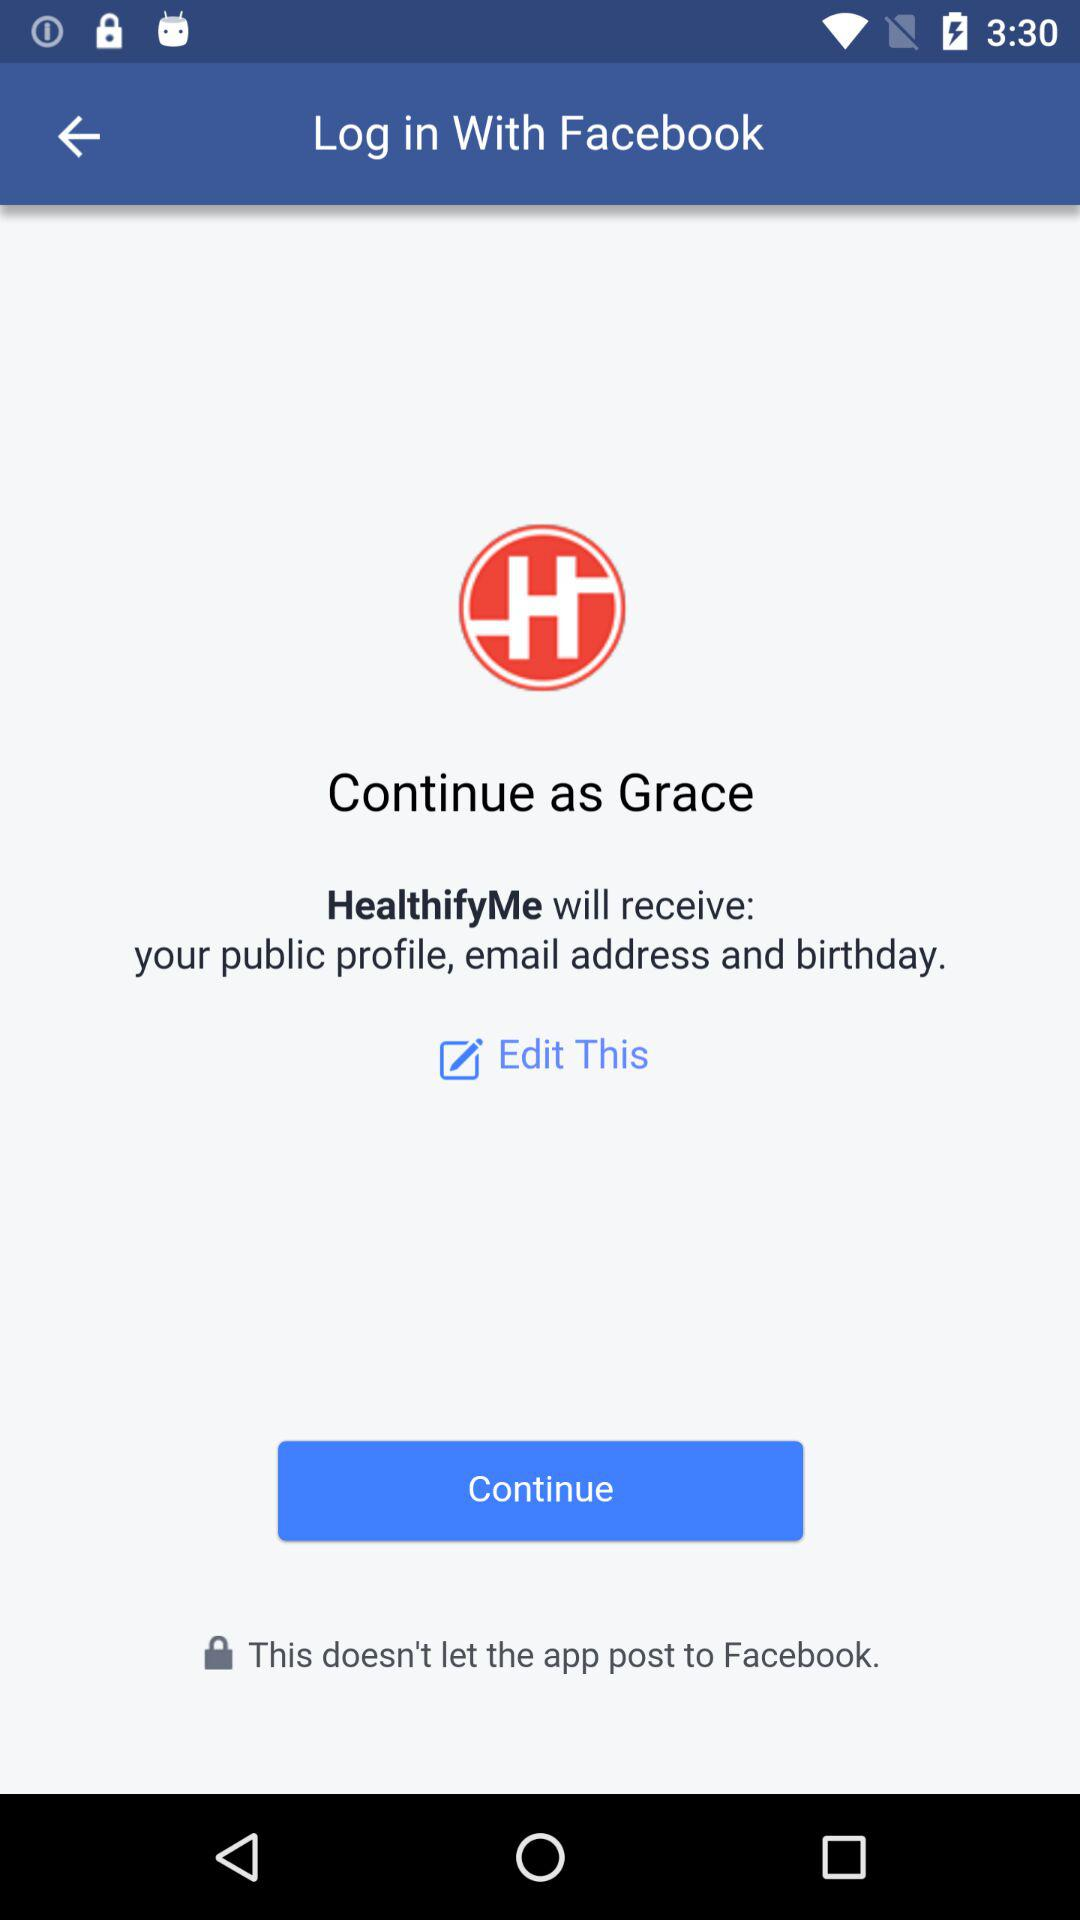What application will receive my public profile, email address and birthday? The application is "HealthifyMe". 